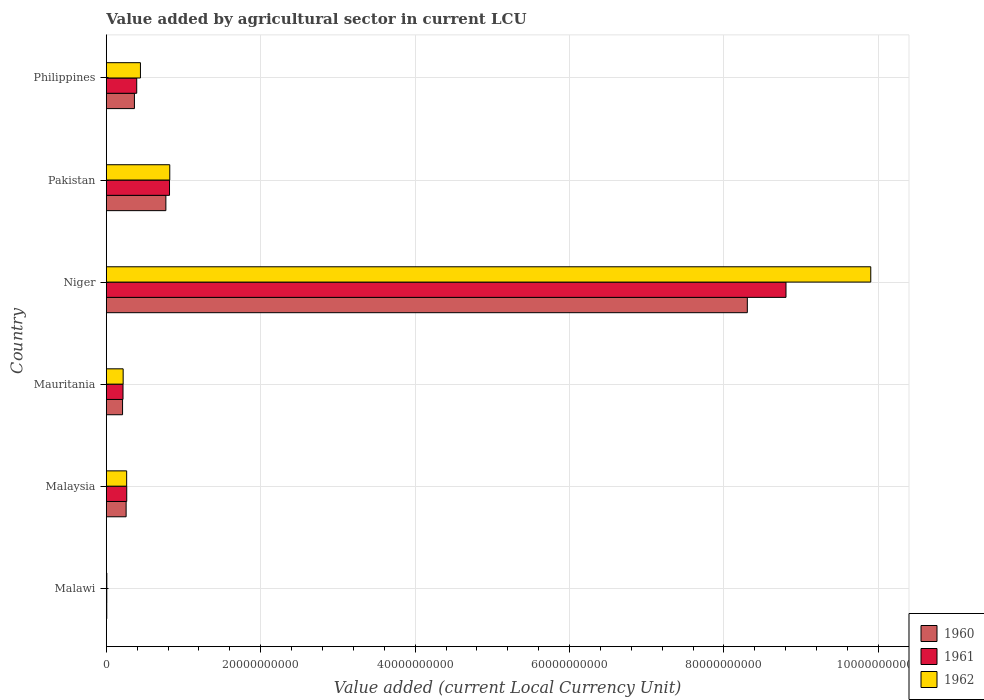Are the number of bars on each tick of the Y-axis equal?
Your response must be concise. Yes. How many bars are there on the 1st tick from the top?
Ensure brevity in your answer.  3. In how many cases, is the number of bars for a given country not equal to the number of legend labels?
Provide a short and direct response. 0. What is the value added by agricultural sector in 1960 in Malawi?
Provide a short and direct response. 5.63e+07. Across all countries, what is the maximum value added by agricultural sector in 1962?
Your answer should be very brief. 9.90e+1. Across all countries, what is the minimum value added by agricultural sector in 1960?
Ensure brevity in your answer.  5.63e+07. In which country was the value added by agricultural sector in 1961 maximum?
Provide a succinct answer. Niger. In which country was the value added by agricultural sector in 1961 minimum?
Keep it short and to the point. Malawi. What is the total value added by agricultural sector in 1961 in the graph?
Offer a terse response. 1.05e+11. What is the difference between the value added by agricultural sector in 1961 in Pakistan and that in Philippines?
Keep it short and to the point. 4.25e+09. What is the difference between the value added by agricultural sector in 1962 in Malawi and the value added by agricultural sector in 1961 in Malaysia?
Your answer should be compact. -2.58e+09. What is the average value added by agricultural sector in 1962 per country?
Your response must be concise. 1.94e+1. What is the difference between the value added by agricultural sector in 1960 and value added by agricultural sector in 1962 in Pakistan?
Keep it short and to the point. -5.05e+08. What is the ratio of the value added by agricultural sector in 1962 in Malaysia to that in Philippines?
Offer a very short reply. 0.6. Is the difference between the value added by agricultural sector in 1960 in Niger and Philippines greater than the difference between the value added by agricultural sector in 1962 in Niger and Philippines?
Your answer should be compact. No. What is the difference between the highest and the second highest value added by agricultural sector in 1960?
Ensure brevity in your answer.  7.53e+1. What is the difference between the highest and the lowest value added by agricultural sector in 1960?
Your answer should be very brief. 8.30e+1. In how many countries, is the value added by agricultural sector in 1960 greater than the average value added by agricultural sector in 1960 taken over all countries?
Make the answer very short. 1. What does the 3rd bar from the top in Niger represents?
Your answer should be very brief. 1960. Is it the case that in every country, the sum of the value added by agricultural sector in 1961 and value added by agricultural sector in 1962 is greater than the value added by agricultural sector in 1960?
Your answer should be compact. Yes. How many bars are there?
Offer a very short reply. 18. Are the values on the major ticks of X-axis written in scientific E-notation?
Make the answer very short. No. Does the graph contain grids?
Your response must be concise. Yes. Where does the legend appear in the graph?
Your answer should be very brief. Bottom right. How are the legend labels stacked?
Keep it short and to the point. Vertical. What is the title of the graph?
Your answer should be very brief. Value added by agricultural sector in current LCU. What is the label or title of the X-axis?
Make the answer very short. Value added (current Local Currency Unit). What is the label or title of the Y-axis?
Keep it short and to the point. Country. What is the Value added (current Local Currency Unit) in 1960 in Malawi?
Your answer should be compact. 5.63e+07. What is the Value added (current Local Currency Unit) in 1961 in Malawi?
Offer a terse response. 6.06e+07. What is the Value added (current Local Currency Unit) of 1962 in Malawi?
Offer a terse response. 6.36e+07. What is the Value added (current Local Currency Unit) in 1960 in Malaysia?
Give a very brief answer. 2.56e+09. What is the Value added (current Local Currency Unit) in 1961 in Malaysia?
Give a very brief answer. 2.64e+09. What is the Value added (current Local Currency Unit) in 1962 in Malaysia?
Ensure brevity in your answer.  2.63e+09. What is the Value added (current Local Currency Unit) in 1960 in Mauritania?
Keep it short and to the point. 2.10e+09. What is the Value added (current Local Currency Unit) in 1961 in Mauritania?
Make the answer very short. 2.16e+09. What is the Value added (current Local Currency Unit) of 1962 in Mauritania?
Provide a short and direct response. 2.18e+09. What is the Value added (current Local Currency Unit) in 1960 in Niger?
Your answer should be compact. 8.30e+1. What is the Value added (current Local Currency Unit) in 1961 in Niger?
Ensure brevity in your answer.  8.80e+1. What is the Value added (current Local Currency Unit) in 1962 in Niger?
Offer a very short reply. 9.90e+1. What is the Value added (current Local Currency Unit) in 1960 in Pakistan?
Provide a short and direct response. 7.71e+09. What is the Value added (current Local Currency Unit) of 1961 in Pakistan?
Provide a succinct answer. 8.18e+09. What is the Value added (current Local Currency Unit) of 1962 in Pakistan?
Ensure brevity in your answer.  8.22e+09. What is the Value added (current Local Currency Unit) of 1960 in Philippines?
Ensure brevity in your answer.  3.64e+09. What is the Value added (current Local Currency Unit) of 1961 in Philippines?
Give a very brief answer. 3.94e+09. What is the Value added (current Local Currency Unit) in 1962 in Philippines?
Provide a short and direct response. 4.42e+09. Across all countries, what is the maximum Value added (current Local Currency Unit) in 1960?
Offer a very short reply. 8.30e+1. Across all countries, what is the maximum Value added (current Local Currency Unit) in 1961?
Give a very brief answer. 8.80e+1. Across all countries, what is the maximum Value added (current Local Currency Unit) of 1962?
Provide a short and direct response. 9.90e+1. Across all countries, what is the minimum Value added (current Local Currency Unit) of 1960?
Offer a terse response. 5.63e+07. Across all countries, what is the minimum Value added (current Local Currency Unit) of 1961?
Ensure brevity in your answer.  6.06e+07. Across all countries, what is the minimum Value added (current Local Currency Unit) of 1962?
Your response must be concise. 6.36e+07. What is the total Value added (current Local Currency Unit) in 1960 in the graph?
Your response must be concise. 9.91e+1. What is the total Value added (current Local Currency Unit) in 1961 in the graph?
Keep it short and to the point. 1.05e+11. What is the total Value added (current Local Currency Unit) in 1962 in the graph?
Give a very brief answer. 1.17e+11. What is the difference between the Value added (current Local Currency Unit) in 1960 in Malawi and that in Malaysia?
Offer a very short reply. -2.51e+09. What is the difference between the Value added (current Local Currency Unit) in 1961 in Malawi and that in Malaysia?
Keep it short and to the point. -2.58e+09. What is the difference between the Value added (current Local Currency Unit) of 1962 in Malawi and that in Malaysia?
Offer a terse response. -2.57e+09. What is the difference between the Value added (current Local Currency Unit) of 1960 in Malawi and that in Mauritania?
Offer a terse response. -2.05e+09. What is the difference between the Value added (current Local Currency Unit) in 1961 in Malawi and that in Mauritania?
Provide a short and direct response. -2.10e+09. What is the difference between the Value added (current Local Currency Unit) in 1962 in Malawi and that in Mauritania?
Keep it short and to the point. -2.12e+09. What is the difference between the Value added (current Local Currency Unit) in 1960 in Malawi and that in Niger?
Offer a very short reply. -8.30e+1. What is the difference between the Value added (current Local Currency Unit) in 1961 in Malawi and that in Niger?
Keep it short and to the point. -8.80e+1. What is the difference between the Value added (current Local Currency Unit) of 1962 in Malawi and that in Niger?
Ensure brevity in your answer.  -9.89e+1. What is the difference between the Value added (current Local Currency Unit) of 1960 in Malawi and that in Pakistan?
Keep it short and to the point. -7.65e+09. What is the difference between the Value added (current Local Currency Unit) of 1961 in Malawi and that in Pakistan?
Your answer should be very brief. -8.12e+09. What is the difference between the Value added (current Local Currency Unit) in 1962 in Malawi and that in Pakistan?
Your answer should be compact. -8.15e+09. What is the difference between the Value added (current Local Currency Unit) of 1960 in Malawi and that in Philippines?
Offer a very short reply. -3.58e+09. What is the difference between the Value added (current Local Currency Unit) of 1961 in Malawi and that in Philippines?
Offer a terse response. -3.87e+09. What is the difference between the Value added (current Local Currency Unit) in 1962 in Malawi and that in Philippines?
Provide a succinct answer. -4.35e+09. What is the difference between the Value added (current Local Currency Unit) of 1960 in Malaysia and that in Mauritania?
Offer a terse response. 4.61e+08. What is the difference between the Value added (current Local Currency Unit) in 1961 in Malaysia and that in Mauritania?
Provide a short and direct response. 4.82e+08. What is the difference between the Value added (current Local Currency Unit) of 1962 in Malaysia and that in Mauritania?
Offer a very short reply. 4.54e+08. What is the difference between the Value added (current Local Currency Unit) of 1960 in Malaysia and that in Niger?
Ensure brevity in your answer.  -8.05e+1. What is the difference between the Value added (current Local Currency Unit) of 1961 in Malaysia and that in Niger?
Your answer should be compact. -8.54e+1. What is the difference between the Value added (current Local Currency Unit) in 1962 in Malaysia and that in Niger?
Keep it short and to the point. -9.64e+1. What is the difference between the Value added (current Local Currency Unit) in 1960 in Malaysia and that in Pakistan?
Your answer should be very brief. -5.15e+09. What is the difference between the Value added (current Local Currency Unit) of 1961 in Malaysia and that in Pakistan?
Make the answer very short. -5.54e+09. What is the difference between the Value added (current Local Currency Unit) in 1962 in Malaysia and that in Pakistan?
Offer a very short reply. -5.58e+09. What is the difference between the Value added (current Local Currency Unit) of 1960 in Malaysia and that in Philippines?
Your answer should be very brief. -1.07e+09. What is the difference between the Value added (current Local Currency Unit) of 1961 in Malaysia and that in Philippines?
Your answer should be compact. -1.29e+09. What is the difference between the Value added (current Local Currency Unit) in 1962 in Malaysia and that in Philippines?
Offer a terse response. -1.78e+09. What is the difference between the Value added (current Local Currency Unit) of 1960 in Mauritania and that in Niger?
Keep it short and to the point. -8.09e+1. What is the difference between the Value added (current Local Currency Unit) in 1961 in Mauritania and that in Niger?
Keep it short and to the point. -8.59e+1. What is the difference between the Value added (current Local Currency Unit) in 1962 in Mauritania and that in Niger?
Provide a succinct answer. -9.68e+1. What is the difference between the Value added (current Local Currency Unit) in 1960 in Mauritania and that in Pakistan?
Give a very brief answer. -5.61e+09. What is the difference between the Value added (current Local Currency Unit) of 1961 in Mauritania and that in Pakistan?
Provide a short and direct response. -6.02e+09. What is the difference between the Value added (current Local Currency Unit) of 1962 in Mauritania and that in Pakistan?
Offer a terse response. -6.04e+09. What is the difference between the Value added (current Local Currency Unit) of 1960 in Mauritania and that in Philippines?
Your answer should be compact. -1.54e+09. What is the difference between the Value added (current Local Currency Unit) in 1961 in Mauritania and that in Philippines?
Your answer should be very brief. -1.78e+09. What is the difference between the Value added (current Local Currency Unit) of 1962 in Mauritania and that in Philippines?
Provide a short and direct response. -2.24e+09. What is the difference between the Value added (current Local Currency Unit) of 1960 in Niger and that in Pakistan?
Your answer should be very brief. 7.53e+1. What is the difference between the Value added (current Local Currency Unit) in 1961 in Niger and that in Pakistan?
Provide a short and direct response. 7.98e+1. What is the difference between the Value added (current Local Currency Unit) of 1962 in Niger and that in Pakistan?
Offer a terse response. 9.08e+1. What is the difference between the Value added (current Local Currency Unit) in 1960 in Niger and that in Philippines?
Keep it short and to the point. 7.94e+1. What is the difference between the Value added (current Local Currency Unit) of 1961 in Niger and that in Philippines?
Keep it short and to the point. 8.41e+1. What is the difference between the Value added (current Local Currency Unit) in 1962 in Niger and that in Philippines?
Keep it short and to the point. 9.46e+1. What is the difference between the Value added (current Local Currency Unit) in 1960 in Pakistan and that in Philippines?
Your answer should be very brief. 4.07e+09. What is the difference between the Value added (current Local Currency Unit) in 1961 in Pakistan and that in Philippines?
Ensure brevity in your answer.  4.25e+09. What is the difference between the Value added (current Local Currency Unit) of 1962 in Pakistan and that in Philippines?
Offer a terse response. 3.80e+09. What is the difference between the Value added (current Local Currency Unit) in 1960 in Malawi and the Value added (current Local Currency Unit) in 1961 in Malaysia?
Make the answer very short. -2.59e+09. What is the difference between the Value added (current Local Currency Unit) in 1960 in Malawi and the Value added (current Local Currency Unit) in 1962 in Malaysia?
Give a very brief answer. -2.58e+09. What is the difference between the Value added (current Local Currency Unit) in 1961 in Malawi and the Value added (current Local Currency Unit) in 1962 in Malaysia?
Your response must be concise. -2.57e+09. What is the difference between the Value added (current Local Currency Unit) in 1960 in Malawi and the Value added (current Local Currency Unit) in 1961 in Mauritania?
Give a very brief answer. -2.10e+09. What is the difference between the Value added (current Local Currency Unit) in 1960 in Malawi and the Value added (current Local Currency Unit) in 1962 in Mauritania?
Offer a very short reply. -2.12e+09. What is the difference between the Value added (current Local Currency Unit) of 1961 in Malawi and the Value added (current Local Currency Unit) of 1962 in Mauritania?
Your response must be concise. -2.12e+09. What is the difference between the Value added (current Local Currency Unit) in 1960 in Malawi and the Value added (current Local Currency Unit) in 1961 in Niger?
Your response must be concise. -8.80e+1. What is the difference between the Value added (current Local Currency Unit) in 1960 in Malawi and the Value added (current Local Currency Unit) in 1962 in Niger?
Your response must be concise. -9.90e+1. What is the difference between the Value added (current Local Currency Unit) in 1961 in Malawi and the Value added (current Local Currency Unit) in 1962 in Niger?
Your response must be concise. -9.90e+1. What is the difference between the Value added (current Local Currency Unit) in 1960 in Malawi and the Value added (current Local Currency Unit) in 1961 in Pakistan?
Keep it short and to the point. -8.13e+09. What is the difference between the Value added (current Local Currency Unit) in 1960 in Malawi and the Value added (current Local Currency Unit) in 1962 in Pakistan?
Ensure brevity in your answer.  -8.16e+09. What is the difference between the Value added (current Local Currency Unit) in 1961 in Malawi and the Value added (current Local Currency Unit) in 1962 in Pakistan?
Ensure brevity in your answer.  -8.16e+09. What is the difference between the Value added (current Local Currency Unit) in 1960 in Malawi and the Value added (current Local Currency Unit) in 1961 in Philippines?
Give a very brief answer. -3.88e+09. What is the difference between the Value added (current Local Currency Unit) of 1960 in Malawi and the Value added (current Local Currency Unit) of 1962 in Philippines?
Offer a terse response. -4.36e+09. What is the difference between the Value added (current Local Currency Unit) in 1961 in Malawi and the Value added (current Local Currency Unit) in 1962 in Philippines?
Provide a short and direct response. -4.36e+09. What is the difference between the Value added (current Local Currency Unit) of 1960 in Malaysia and the Value added (current Local Currency Unit) of 1961 in Mauritania?
Provide a short and direct response. 4.04e+08. What is the difference between the Value added (current Local Currency Unit) in 1960 in Malaysia and the Value added (current Local Currency Unit) in 1962 in Mauritania?
Your answer should be very brief. 3.86e+08. What is the difference between the Value added (current Local Currency Unit) in 1961 in Malaysia and the Value added (current Local Currency Unit) in 1962 in Mauritania?
Provide a short and direct response. 4.63e+08. What is the difference between the Value added (current Local Currency Unit) in 1960 in Malaysia and the Value added (current Local Currency Unit) in 1961 in Niger?
Give a very brief answer. -8.55e+1. What is the difference between the Value added (current Local Currency Unit) in 1960 in Malaysia and the Value added (current Local Currency Unit) in 1962 in Niger?
Keep it short and to the point. -9.64e+1. What is the difference between the Value added (current Local Currency Unit) of 1961 in Malaysia and the Value added (current Local Currency Unit) of 1962 in Niger?
Keep it short and to the point. -9.64e+1. What is the difference between the Value added (current Local Currency Unit) in 1960 in Malaysia and the Value added (current Local Currency Unit) in 1961 in Pakistan?
Offer a terse response. -5.62e+09. What is the difference between the Value added (current Local Currency Unit) in 1960 in Malaysia and the Value added (current Local Currency Unit) in 1962 in Pakistan?
Ensure brevity in your answer.  -5.65e+09. What is the difference between the Value added (current Local Currency Unit) of 1961 in Malaysia and the Value added (current Local Currency Unit) of 1962 in Pakistan?
Your answer should be very brief. -5.57e+09. What is the difference between the Value added (current Local Currency Unit) of 1960 in Malaysia and the Value added (current Local Currency Unit) of 1961 in Philippines?
Give a very brief answer. -1.37e+09. What is the difference between the Value added (current Local Currency Unit) in 1960 in Malaysia and the Value added (current Local Currency Unit) in 1962 in Philippines?
Your response must be concise. -1.85e+09. What is the difference between the Value added (current Local Currency Unit) in 1961 in Malaysia and the Value added (current Local Currency Unit) in 1962 in Philippines?
Your answer should be very brief. -1.77e+09. What is the difference between the Value added (current Local Currency Unit) of 1960 in Mauritania and the Value added (current Local Currency Unit) of 1961 in Niger?
Offer a terse response. -8.59e+1. What is the difference between the Value added (current Local Currency Unit) of 1960 in Mauritania and the Value added (current Local Currency Unit) of 1962 in Niger?
Provide a short and direct response. -9.69e+1. What is the difference between the Value added (current Local Currency Unit) in 1961 in Mauritania and the Value added (current Local Currency Unit) in 1962 in Niger?
Your answer should be compact. -9.69e+1. What is the difference between the Value added (current Local Currency Unit) of 1960 in Mauritania and the Value added (current Local Currency Unit) of 1961 in Pakistan?
Keep it short and to the point. -6.08e+09. What is the difference between the Value added (current Local Currency Unit) of 1960 in Mauritania and the Value added (current Local Currency Unit) of 1962 in Pakistan?
Give a very brief answer. -6.11e+09. What is the difference between the Value added (current Local Currency Unit) in 1961 in Mauritania and the Value added (current Local Currency Unit) in 1962 in Pakistan?
Your answer should be compact. -6.06e+09. What is the difference between the Value added (current Local Currency Unit) in 1960 in Mauritania and the Value added (current Local Currency Unit) in 1961 in Philippines?
Your answer should be very brief. -1.83e+09. What is the difference between the Value added (current Local Currency Unit) in 1960 in Mauritania and the Value added (current Local Currency Unit) in 1962 in Philippines?
Your response must be concise. -2.31e+09. What is the difference between the Value added (current Local Currency Unit) of 1961 in Mauritania and the Value added (current Local Currency Unit) of 1962 in Philippines?
Keep it short and to the point. -2.26e+09. What is the difference between the Value added (current Local Currency Unit) of 1960 in Niger and the Value added (current Local Currency Unit) of 1961 in Pakistan?
Make the answer very short. 7.48e+1. What is the difference between the Value added (current Local Currency Unit) of 1960 in Niger and the Value added (current Local Currency Unit) of 1962 in Pakistan?
Offer a terse response. 7.48e+1. What is the difference between the Value added (current Local Currency Unit) in 1961 in Niger and the Value added (current Local Currency Unit) in 1962 in Pakistan?
Offer a terse response. 7.98e+1. What is the difference between the Value added (current Local Currency Unit) of 1960 in Niger and the Value added (current Local Currency Unit) of 1961 in Philippines?
Keep it short and to the point. 7.91e+1. What is the difference between the Value added (current Local Currency Unit) in 1960 in Niger and the Value added (current Local Currency Unit) in 1962 in Philippines?
Offer a terse response. 7.86e+1. What is the difference between the Value added (current Local Currency Unit) of 1961 in Niger and the Value added (current Local Currency Unit) of 1962 in Philippines?
Your response must be concise. 8.36e+1. What is the difference between the Value added (current Local Currency Unit) of 1960 in Pakistan and the Value added (current Local Currency Unit) of 1961 in Philippines?
Your answer should be compact. 3.78e+09. What is the difference between the Value added (current Local Currency Unit) in 1960 in Pakistan and the Value added (current Local Currency Unit) in 1962 in Philippines?
Provide a short and direct response. 3.29e+09. What is the difference between the Value added (current Local Currency Unit) in 1961 in Pakistan and the Value added (current Local Currency Unit) in 1962 in Philippines?
Offer a very short reply. 3.77e+09. What is the average Value added (current Local Currency Unit) in 1960 per country?
Provide a short and direct response. 1.65e+1. What is the average Value added (current Local Currency Unit) in 1961 per country?
Your answer should be compact. 1.75e+1. What is the average Value added (current Local Currency Unit) in 1962 per country?
Provide a short and direct response. 1.94e+1. What is the difference between the Value added (current Local Currency Unit) in 1960 and Value added (current Local Currency Unit) in 1961 in Malawi?
Ensure brevity in your answer.  -4.30e+06. What is the difference between the Value added (current Local Currency Unit) of 1960 and Value added (current Local Currency Unit) of 1962 in Malawi?
Your answer should be very brief. -7.30e+06. What is the difference between the Value added (current Local Currency Unit) of 1960 and Value added (current Local Currency Unit) of 1961 in Malaysia?
Provide a succinct answer. -7.78e+07. What is the difference between the Value added (current Local Currency Unit) in 1960 and Value added (current Local Currency Unit) in 1962 in Malaysia?
Offer a very short reply. -6.83e+07. What is the difference between the Value added (current Local Currency Unit) in 1961 and Value added (current Local Currency Unit) in 1962 in Malaysia?
Offer a terse response. 9.46e+06. What is the difference between the Value added (current Local Currency Unit) of 1960 and Value added (current Local Currency Unit) of 1961 in Mauritania?
Keep it short and to the point. -5.68e+07. What is the difference between the Value added (current Local Currency Unit) of 1960 and Value added (current Local Currency Unit) of 1962 in Mauritania?
Provide a succinct answer. -7.58e+07. What is the difference between the Value added (current Local Currency Unit) of 1961 and Value added (current Local Currency Unit) of 1962 in Mauritania?
Provide a short and direct response. -1.89e+07. What is the difference between the Value added (current Local Currency Unit) of 1960 and Value added (current Local Currency Unit) of 1961 in Niger?
Your answer should be very brief. -5.01e+09. What is the difference between the Value added (current Local Currency Unit) in 1960 and Value added (current Local Currency Unit) in 1962 in Niger?
Give a very brief answer. -1.60e+1. What is the difference between the Value added (current Local Currency Unit) in 1961 and Value added (current Local Currency Unit) in 1962 in Niger?
Keep it short and to the point. -1.10e+1. What is the difference between the Value added (current Local Currency Unit) of 1960 and Value added (current Local Currency Unit) of 1961 in Pakistan?
Your response must be concise. -4.73e+08. What is the difference between the Value added (current Local Currency Unit) in 1960 and Value added (current Local Currency Unit) in 1962 in Pakistan?
Ensure brevity in your answer.  -5.05e+08. What is the difference between the Value added (current Local Currency Unit) of 1961 and Value added (current Local Currency Unit) of 1962 in Pakistan?
Offer a very short reply. -3.20e+07. What is the difference between the Value added (current Local Currency Unit) in 1960 and Value added (current Local Currency Unit) in 1961 in Philippines?
Your response must be concise. -2.97e+08. What is the difference between the Value added (current Local Currency Unit) of 1960 and Value added (current Local Currency Unit) of 1962 in Philippines?
Your response must be concise. -7.78e+08. What is the difference between the Value added (current Local Currency Unit) of 1961 and Value added (current Local Currency Unit) of 1962 in Philippines?
Offer a terse response. -4.81e+08. What is the ratio of the Value added (current Local Currency Unit) of 1960 in Malawi to that in Malaysia?
Your answer should be compact. 0.02. What is the ratio of the Value added (current Local Currency Unit) of 1961 in Malawi to that in Malaysia?
Make the answer very short. 0.02. What is the ratio of the Value added (current Local Currency Unit) in 1962 in Malawi to that in Malaysia?
Provide a succinct answer. 0.02. What is the ratio of the Value added (current Local Currency Unit) of 1960 in Malawi to that in Mauritania?
Your answer should be compact. 0.03. What is the ratio of the Value added (current Local Currency Unit) in 1961 in Malawi to that in Mauritania?
Your answer should be compact. 0.03. What is the ratio of the Value added (current Local Currency Unit) in 1962 in Malawi to that in Mauritania?
Provide a short and direct response. 0.03. What is the ratio of the Value added (current Local Currency Unit) of 1960 in Malawi to that in Niger?
Provide a succinct answer. 0. What is the ratio of the Value added (current Local Currency Unit) of 1961 in Malawi to that in Niger?
Offer a very short reply. 0. What is the ratio of the Value added (current Local Currency Unit) of 1962 in Malawi to that in Niger?
Give a very brief answer. 0. What is the ratio of the Value added (current Local Currency Unit) of 1960 in Malawi to that in Pakistan?
Ensure brevity in your answer.  0.01. What is the ratio of the Value added (current Local Currency Unit) of 1961 in Malawi to that in Pakistan?
Your answer should be very brief. 0.01. What is the ratio of the Value added (current Local Currency Unit) of 1962 in Malawi to that in Pakistan?
Offer a terse response. 0.01. What is the ratio of the Value added (current Local Currency Unit) of 1960 in Malawi to that in Philippines?
Keep it short and to the point. 0.02. What is the ratio of the Value added (current Local Currency Unit) of 1961 in Malawi to that in Philippines?
Your answer should be compact. 0.02. What is the ratio of the Value added (current Local Currency Unit) of 1962 in Malawi to that in Philippines?
Provide a short and direct response. 0.01. What is the ratio of the Value added (current Local Currency Unit) in 1960 in Malaysia to that in Mauritania?
Make the answer very short. 1.22. What is the ratio of the Value added (current Local Currency Unit) in 1961 in Malaysia to that in Mauritania?
Provide a succinct answer. 1.22. What is the ratio of the Value added (current Local Currency Unit) of 1962 in Malaysia to that in Mauritania?
Provide a succinct answer. 1.21. What is the ratio of the Value added (current Local Currency Unit) in 1960 in Malaysia to that in Niger?
Your response must be concise. 0.03. What is the ratio of the Value added (current Local Currency Unit) of 1962 in Malaysia to that in Niger?
Offer a terse response. 0.03. What is the ratio of the Value added (current Local Currency Unit) of 1960 in Malaysia to that in Pakistan?
Keep it short and to the point. 0.33. What is the ratio of the Value added (current Local Currency Unit) in 1961 in Malaysia to that in Pakistan?
Offer a very short reply. 0.32. What is the ratio of the Value added (current Local Currency Unit) of 1962 in Malaysia to that in Pakistan?
Offer a very short reply. 0.32. What is the ratio of the Value added (current Local Currency Unit) in 1960 in Malaysia to that in Philippines?
Your response must be concise. 0.7. What is the ratio of the Value added (current Local Currency Unit) in 1961 in Malaysia to that in Philippines?
Keep it short and to the point. 0.67. What is the ratio of the Value added (current Local Currency Unit) in 1962 in Malaysia to that in Philippines?
Your answer should be compact. 0.6. What is the ratio of the Value added (current Local Currency Unit) of 1960 in Mauritania to that in Niger?
Give a very brief answer. 0.03. What is the ratio of the Value added (current Local Currency Unit) in 1961 in Mauritania to that in Niger?
Make the answer very short. 0.02. What is the ratio of the Value added (current Local Currency Unit) in 1962 in Mauritania to that in Niger?
Your answer should be compact. 0.02. What is the ratio of the Value added (current Local Currency Unit) of 1960 in Mauritania to that in Pakistan?
Make the answer very short. 0.27. What is the ratio of the Value added (current Local Currency Unit) in 1961 in Mauritania to that in Pakistan?
Provide a succinct answer. 0.26. What is the ratio of the Value added (current Local Currency Unit) in 1962 in Mauritania to that in Pakistan?
Make the answer very short. 0.27. What is the ratio of the Value added (current Local Currency Unit) of 1960 in Mauritania to that in Philippines?
Provide a succinct answer. 0.58. What is the ratio of the Value added (current Local Currency Unit) of 1961 in Mauritania to that in Philippines?
Your response must be concise. 0.55. What is the ratio of the Value added (current Local Currency Unit) in 1962 in Mauritania to that in Philippines?
Provide a short and direct response. 0.49. What is the ratio of the Value added (current Local Currency Unit) of 1960 in Niger to that in Pakistan?
Ensure brevity in your answer.  10.77. What is the ratio of the Value added (current Local Currency Unit) in 1961 in Niger to that in Pakistan?
Keep it short and to the point. 10.76. What is the ratio of the Value added (current Local Currency Unit) in 1962 in Niger to that in Pakistan?
Provide a short and direct response. 12.05. What is the ratio of the Value added (current Local Currency Unit) in 1960 in Niger to that in Philippines?
Your response must be concise. 22.82. What is the ratio of the Value added (current Local Currency Unit) of 1961 in Niger to that in Philippines?
Offer a very short reply. 22.37. What is the ratio of the Value added (current Local Currency Unit) in 1962 in Niger to that in Philippines?
Make the answer very short. 22.42. What is the ratio of the Value added (current Local Currency Unit) in 1960 in Pakistan to that in Philippines?
Provide a succinct answer. 2.12. What is the ratio of the Value added (current Local Currency Unit) in 1961 in Pakistan to that in Philippines?
Offer a very short reply. 2.08. What is the ratio of the Value added (current Local Currency Unit) in 1962 in Pakistan to that in Philippines?
Keep it short and to the point. 1.86. What is the difference between the highest and the second highest Value added (current Local Currency Unit) in 1960?
Provide a short and direct response. 7.53e+1. What is the difference between the highest and the second highest Value added (current Local Currency Unit) in 1961?
Keep it short and to the point. 7.98e+1. What is the difference between the highest and the second highest Value added (current Local Currency Unit) of 1962?
Your answer should be very brief. 9.08e+1. What is the difference between the highest and the lowest Value added (current Local Currency Unit) in 1960?
Offer a very short reply. 8.30e+1. What is the difference between the highest and the lowest Value added (current Local Currency Unit) of 1961?
Ensure brevity in your answer.  8.80e+1. What is the difference between the highest and the lowest Value added (current Local Currency Unit) of 1962?
Offer a very short reply. 9.89e+1. 